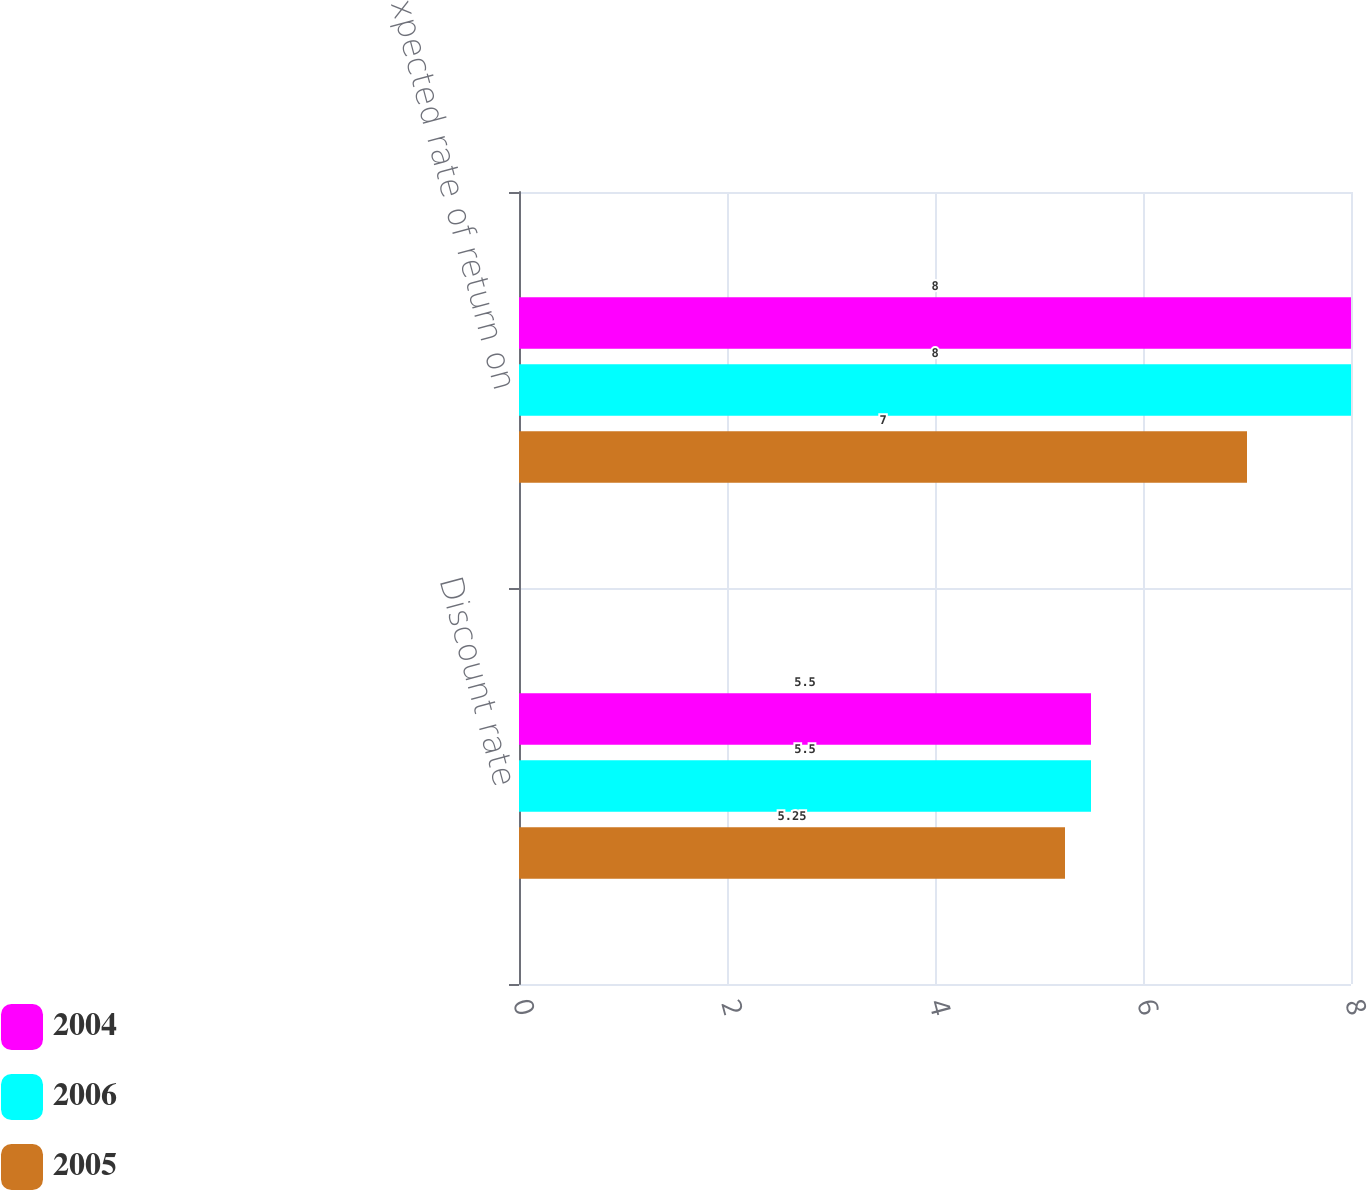<chart> <loc_0><loc_0><loc_500><loc_500><stacked_bar_chart><ecel><fcel>Discount rate<fcel>Expected rate of return on<nl><fcel>2004<fcel>5.5<fcel>8<nl><fcel>2006<fcel>5.5<fcel>8<nl><fcel>2005<fcel>5.25<fcel>7<nl></chart> 